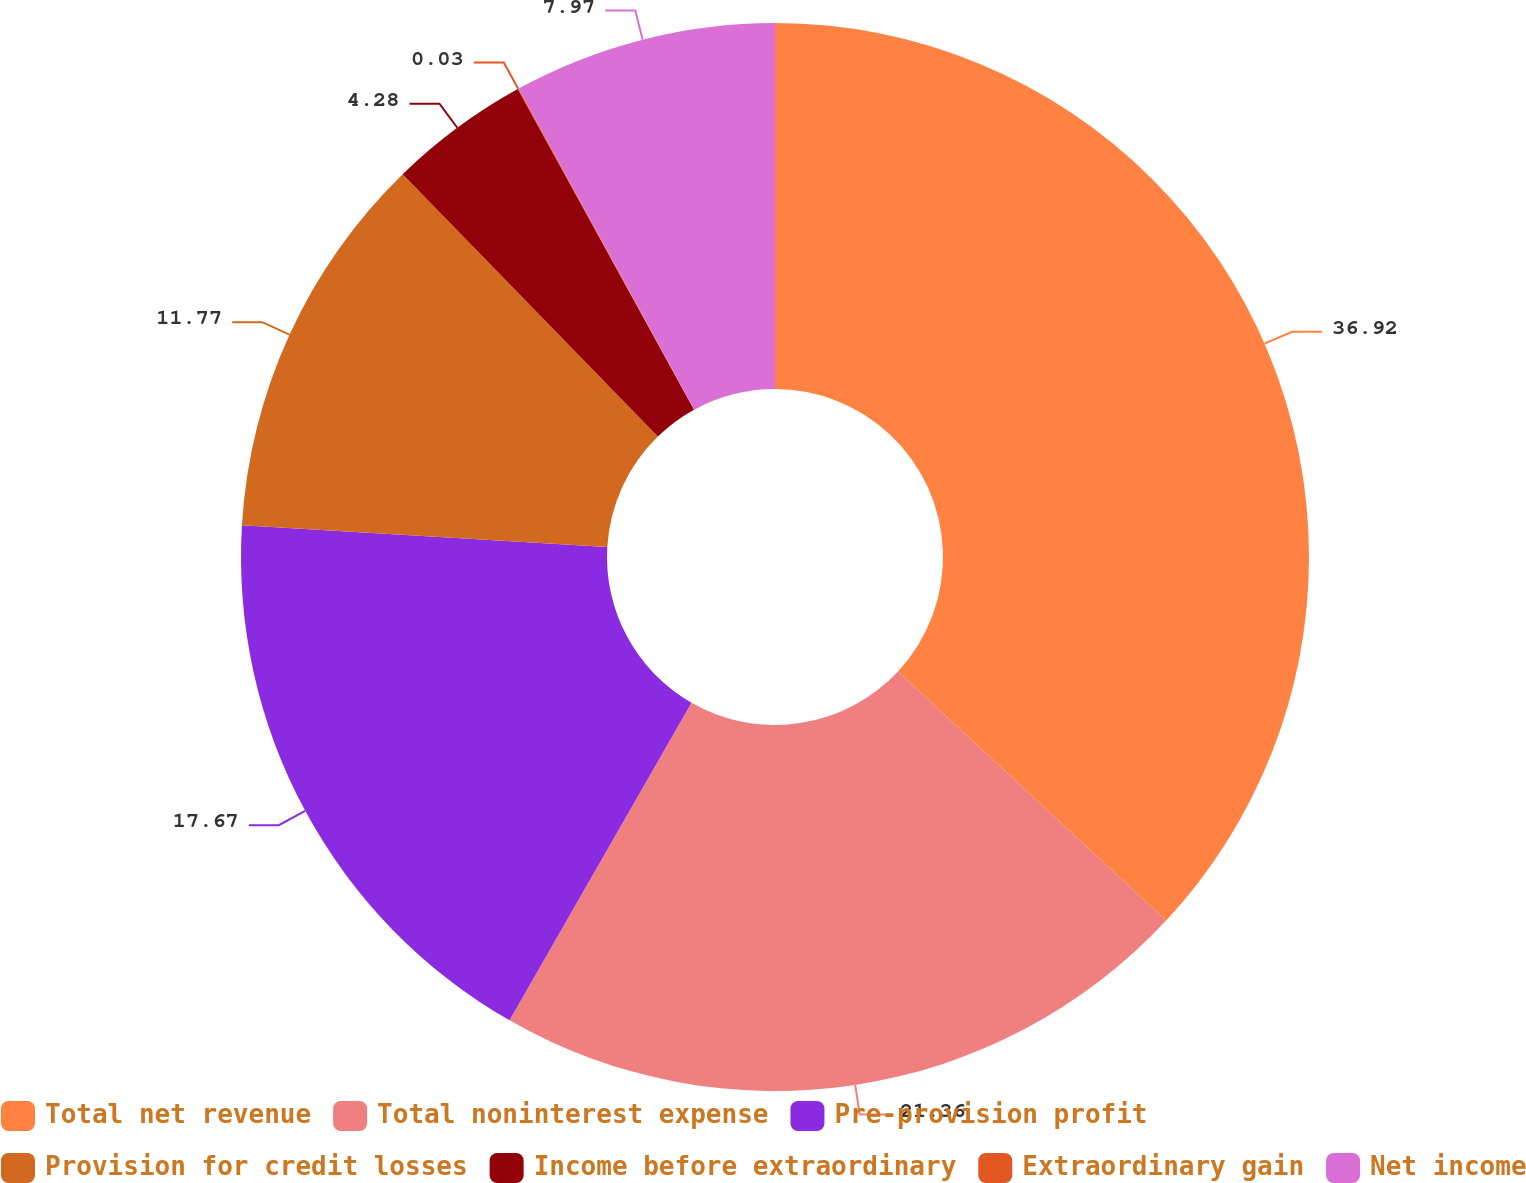Convert chart to OTSL. <chart><loc_0><loc_0><loc_500><loc_500><pie_chart><fcel>Total net revenue<fcel>Total noninterest expense<fcel>Pre-provision profit<fcel>Provision for credit losses<fcel>Income before extraordinary<fcel>Extraordinary gain<fcel>Net income<nl><fcel>36.92%<fcel>21.36%<fcel>17.67%<fcel>11.77%<fcel>4.28%<fcel>0.03%<fcel>7.97%<nl></chart> 